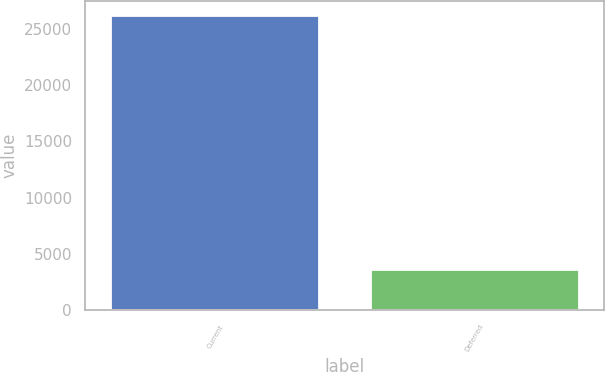<chart> <loc_0><loc_0><loc_500><loc_500><bar_chart><fcel>Current<fcel>Deferred<nl><fcel>26164<fcel>3540<nl></chart> 